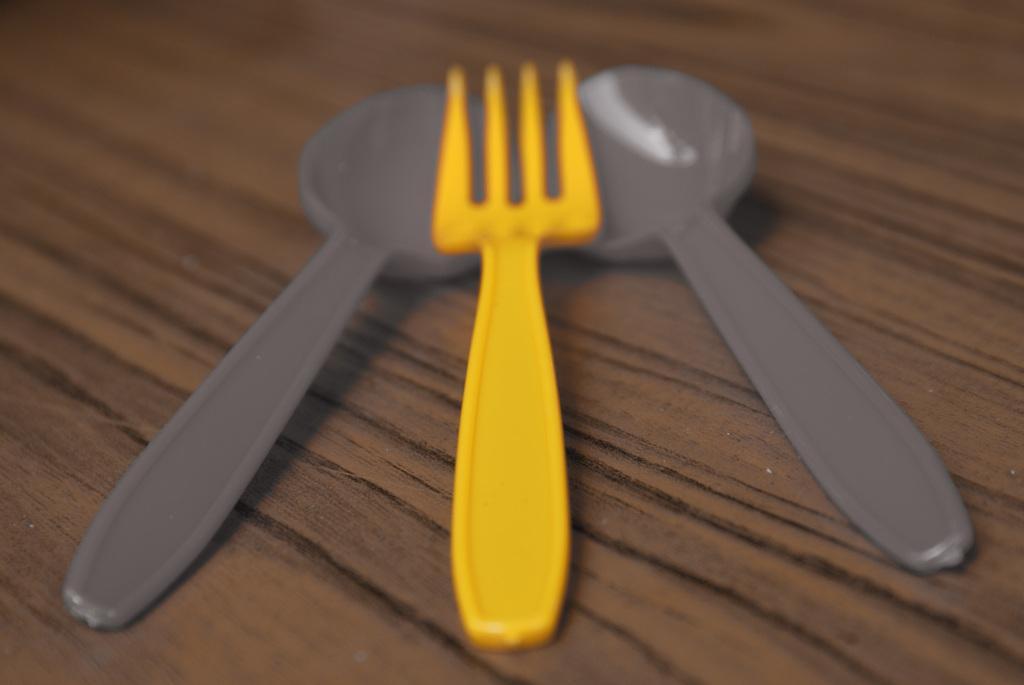How would you summarize this image in a sentence or two? In the image in the center we can see one table. On the table,we can see two spoons and one fork. 